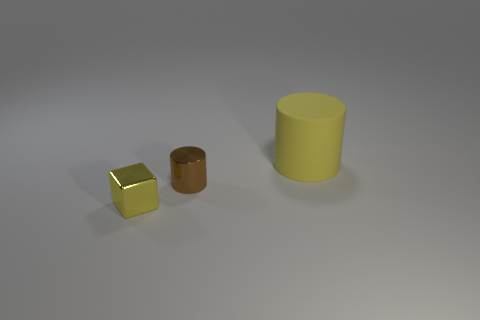Is there any other thing that is the same size as the yellow cylinder?
Offer a terse response. No. Are there any yellow shiny things that have the same shape as the rubber object?
Offer a terse response. No. Is the yellow matte thing the same shape as the tiny brown object?
Give a very brief answer. Yes. There is a small object that is behind the yellow thing that is on the left side of the large rubber cylinder; what color is it?
Your response must be concise. Brown. The metal cylinder that is the same size as the cube is what color?
Offer a very short reply. Brown. How many metallic objects are either blue balls or yellow blocks?
Your answer should be very brief. 1. There is a thing left of the brown metallic cylinder; what number of small shiny things are in front of it?
Offer a terse response. 0. The cylinder that is the same color as the block is what size?
Offer a very short reply. Large. What number of things are either yellow cylinders or objects that are behind the tiny cylinder?
Keep it short and to the point. 1. Is there a big red ball that has the same material as the big object?
Your answer should be very brief. No. 